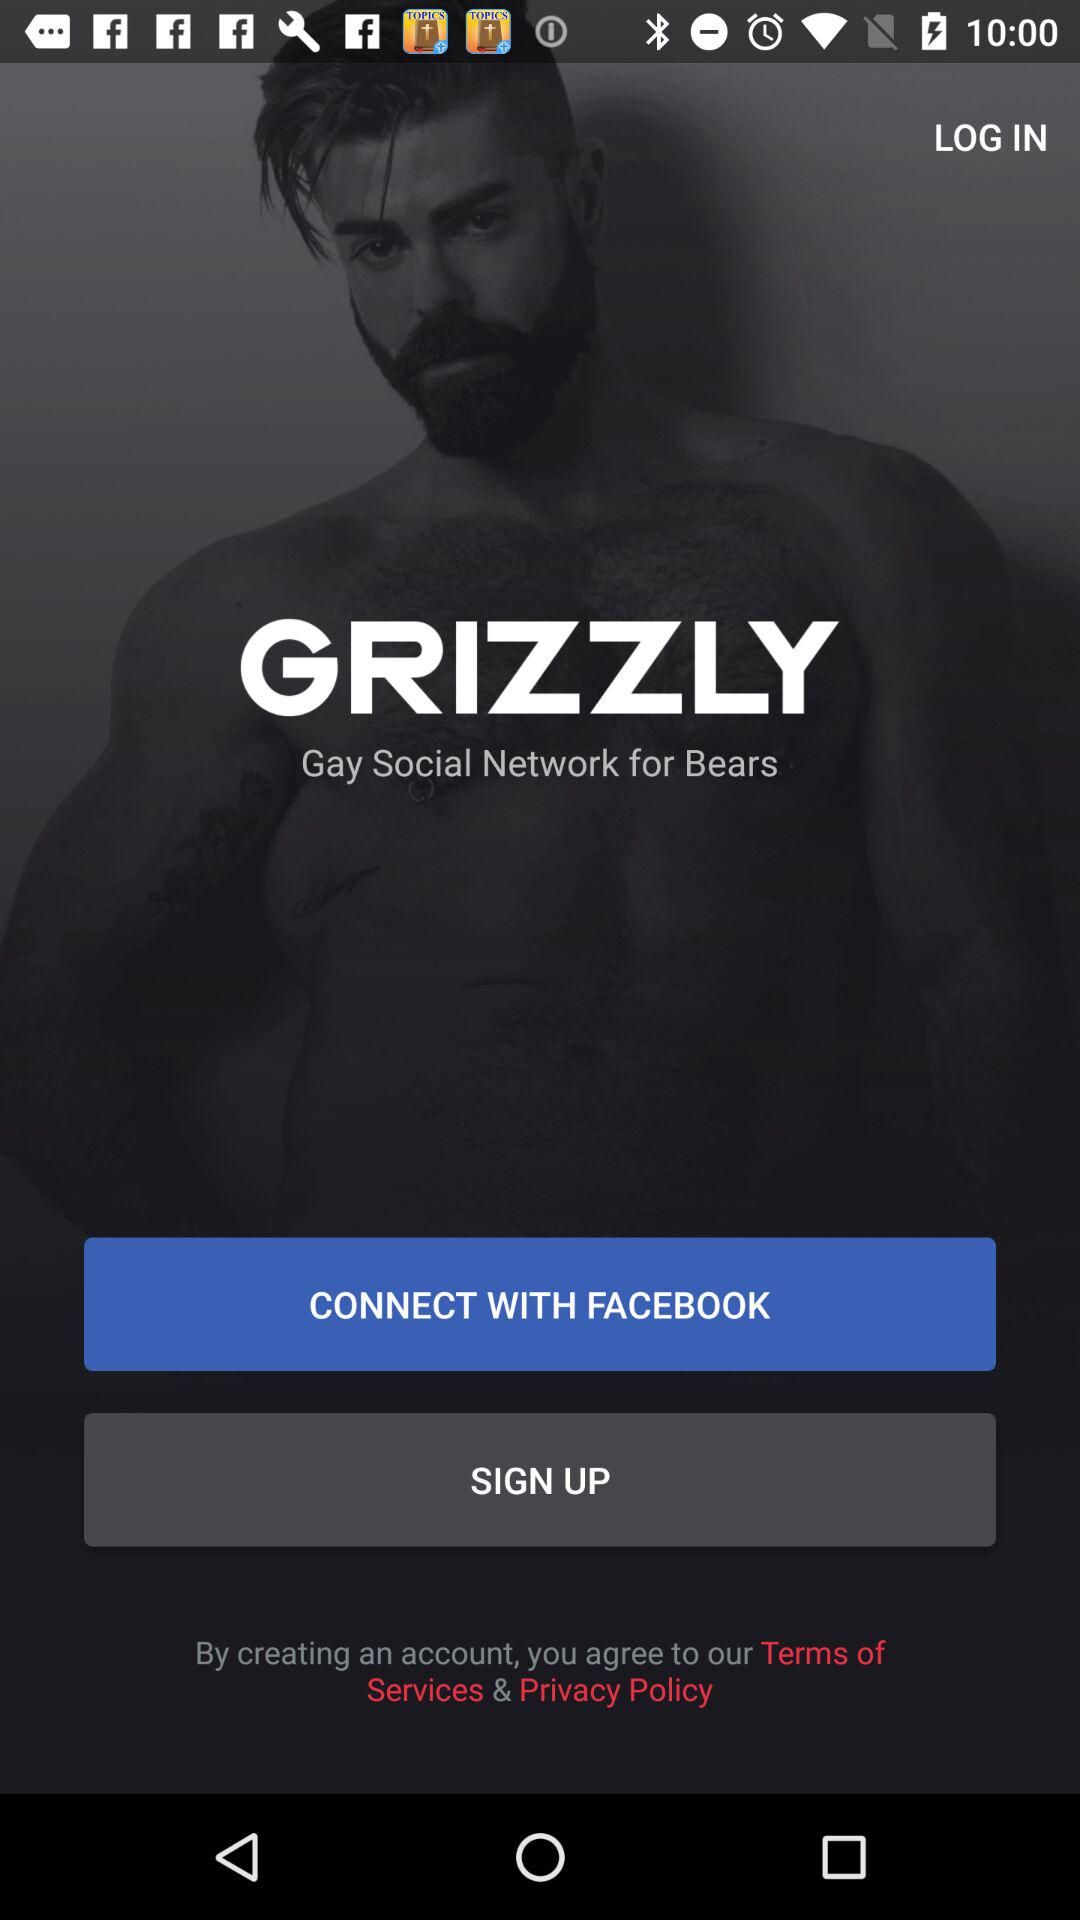What is the other option to connect? The other option to connect is "FACEBOOK". 